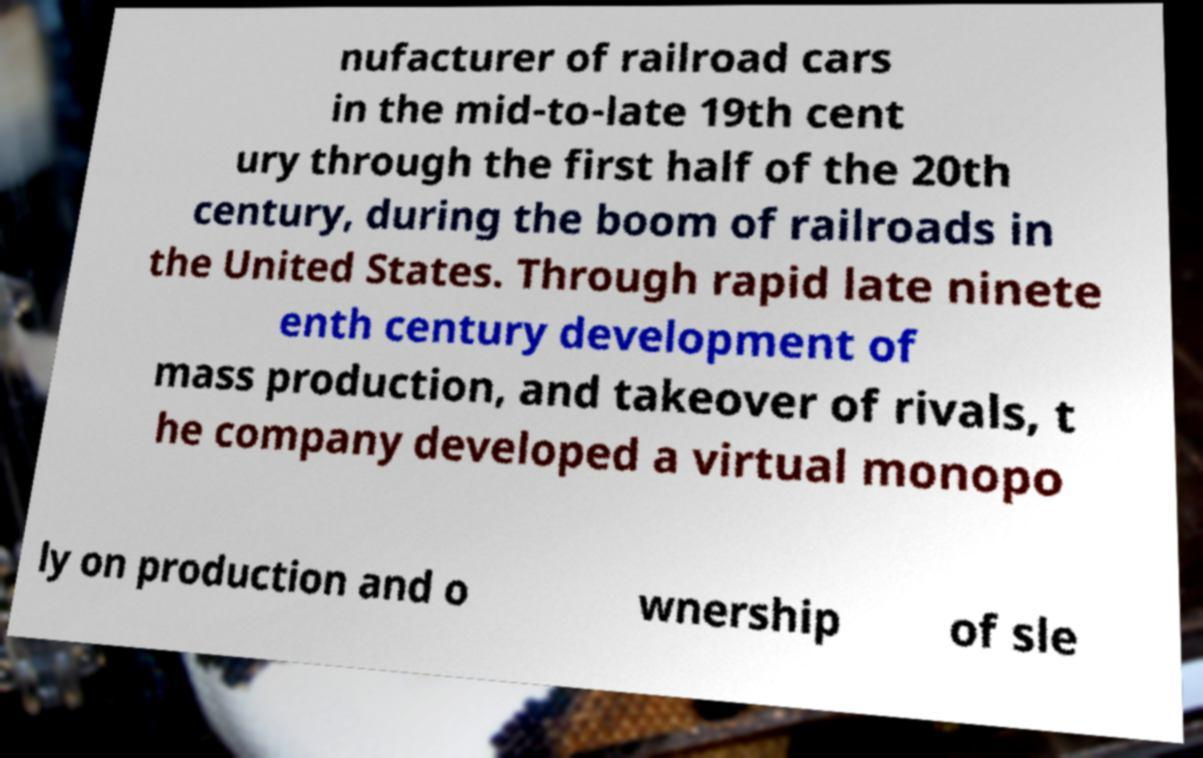I need the written content from this picture converted into text. Can you do that? nufacturer of railroad cars in the mid-to-late 19th cent ury through the first half of the 20th century, during the boom of railroads in the United States. Through rapid late ninete enth century development of mass production, and takeover of rivals, t he company developed a virtual monopo ly on production and o wnership of sle 